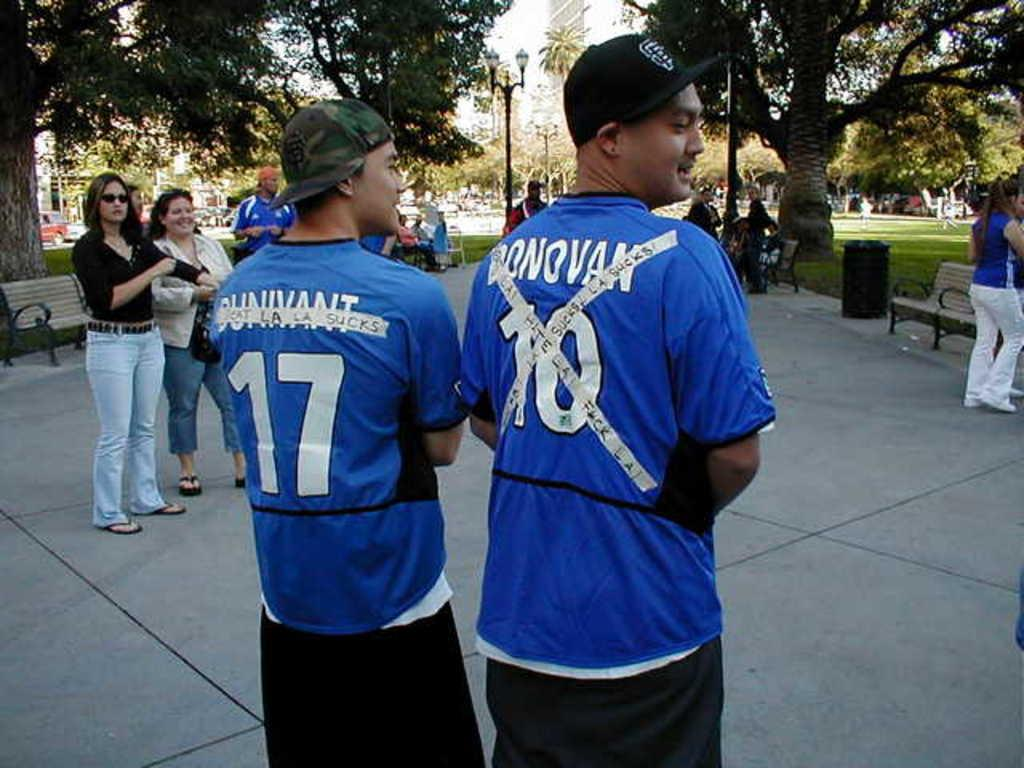<image>
Create a compact narrative representing the image presented. a couple people with the numbers 17 and 10 on them 